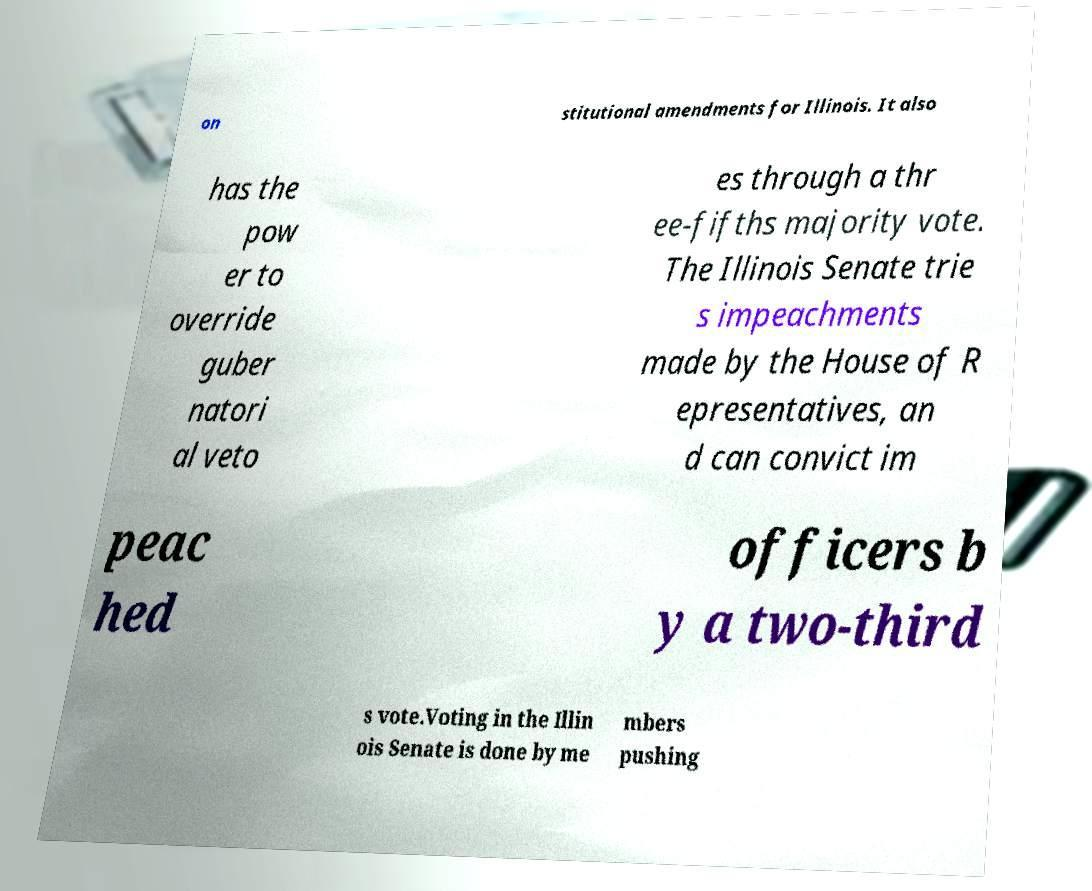Please read and relay the text visible in this image. What does it say? on stitutional amendments for Illinois. It also has the pow er to override guber natori al veto es through a thr ee-fifths majority vote. The Illinois Senate trie s impeachments made by the House of R epresentatives, an d can convict im peac hed officers b y a two-third s vote.Voting in the Illin ois Senate is done by me mbers pushing 